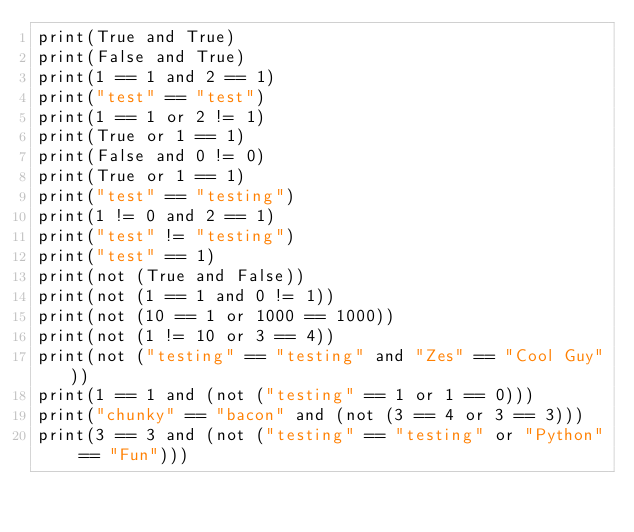<code> <loc_0><loc_0><loc_500><loc_500><_Python_>print(True and True)
print(False and True)
print(1 == 1 and 2 == 1)
print("test" == "test")
print(1 == 1 or 2 != 1)
print(True or 1 == 1)
print(False and 0 != 0)
print(True or 1 == 1)
print("test" == "testing")
print(1 != 0 and 2 == 1)
print("test" != "testing")
print("test" == 1)
print(not (True and False))
print(not (1 == 1 and 0 != 1))
print(not (10 == 1 or 1000 == 1000))
print(not (1 != 10 or 3 == 4))
print(not ("testing" == "testing" and "Zes" == "Cool Guy"))
print(1 == 1 and (not ("testing" == 1 or 1 == 0)))
print("chunky" == "bacon" and (not (3 == 4 or 3 == 3)))
print(3 == 3 and (not ("testing" == "testing" or "Python" == "Fun")))
</code> 